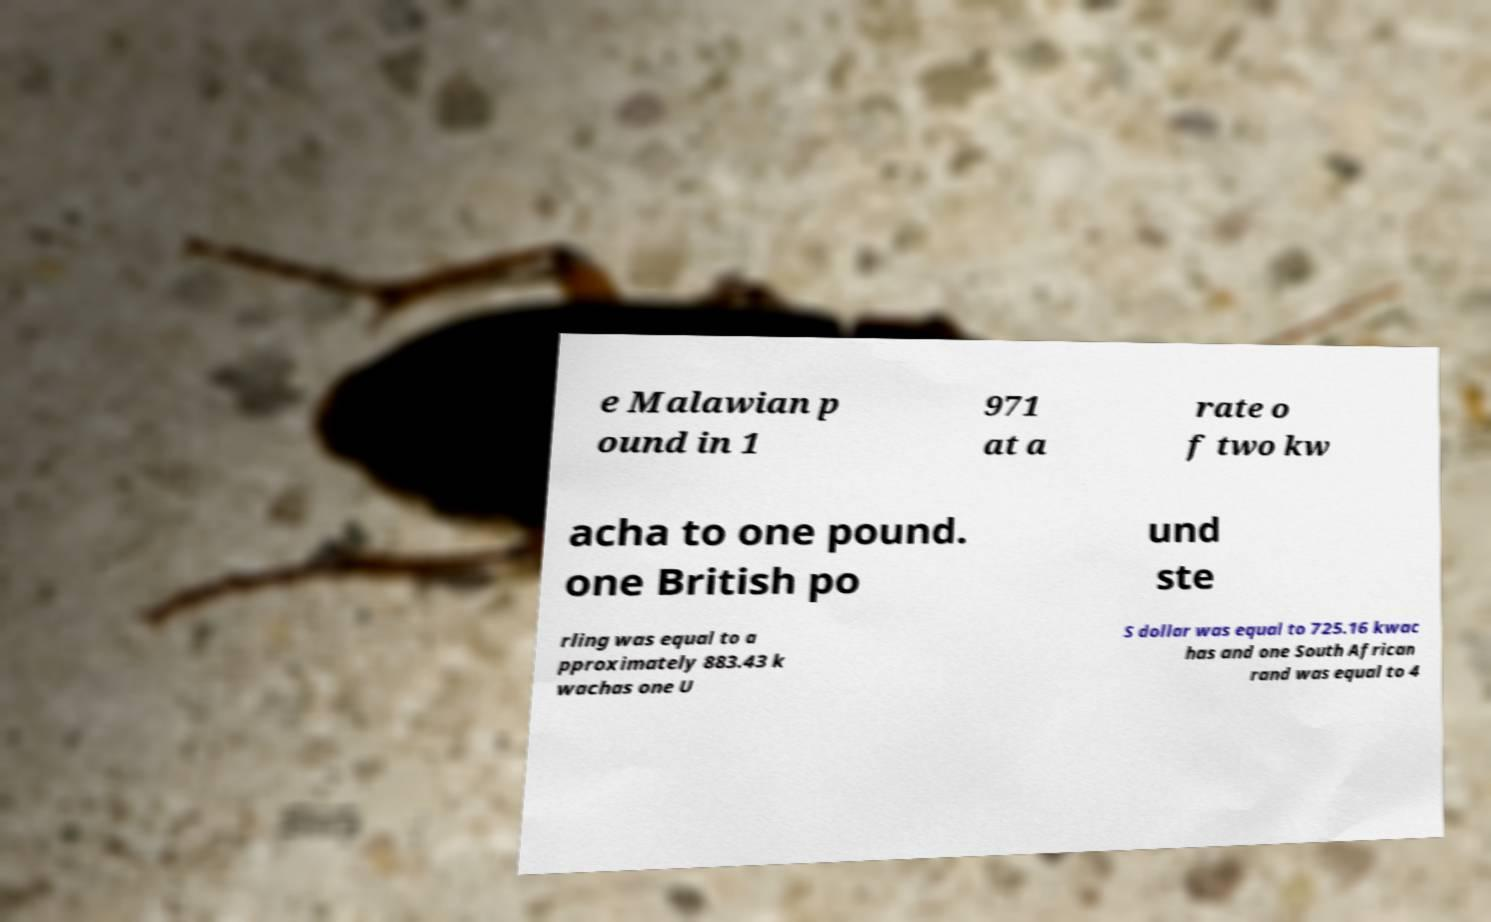I need the written content from this picture converted into text. Can you do that? e Malawian p ound in 1 971 at a rate o f two kw acha to one pound. one British po und ste rling was equal to a pproximately 883.43 k wachas one U S dollar was equal to 725.16 kwac has and one South African rand was equal to 4 